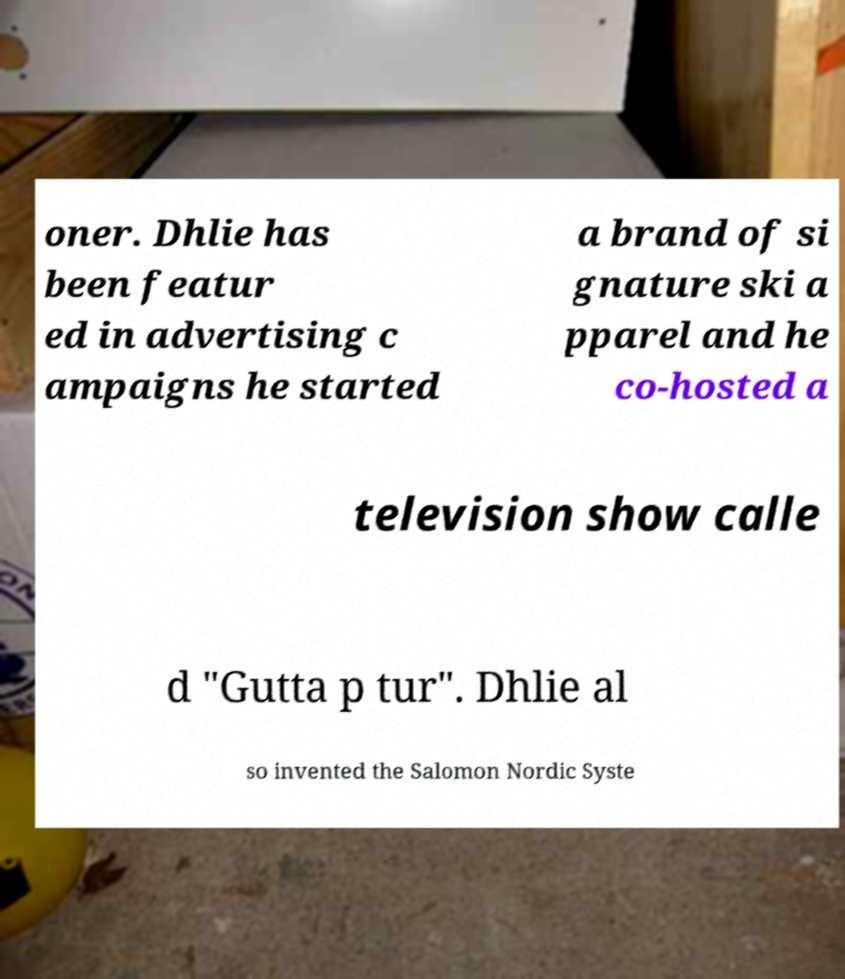I need the written content from this picture converted into text. Can you do that? oner. Dhlie has been featur ed in advertising c ampaigns he started a brand of si gnature ski a pparel and he co-hosted a television show calle d "Gutta p tur". Dhlie al so invented the Salomon Nordic Syste 